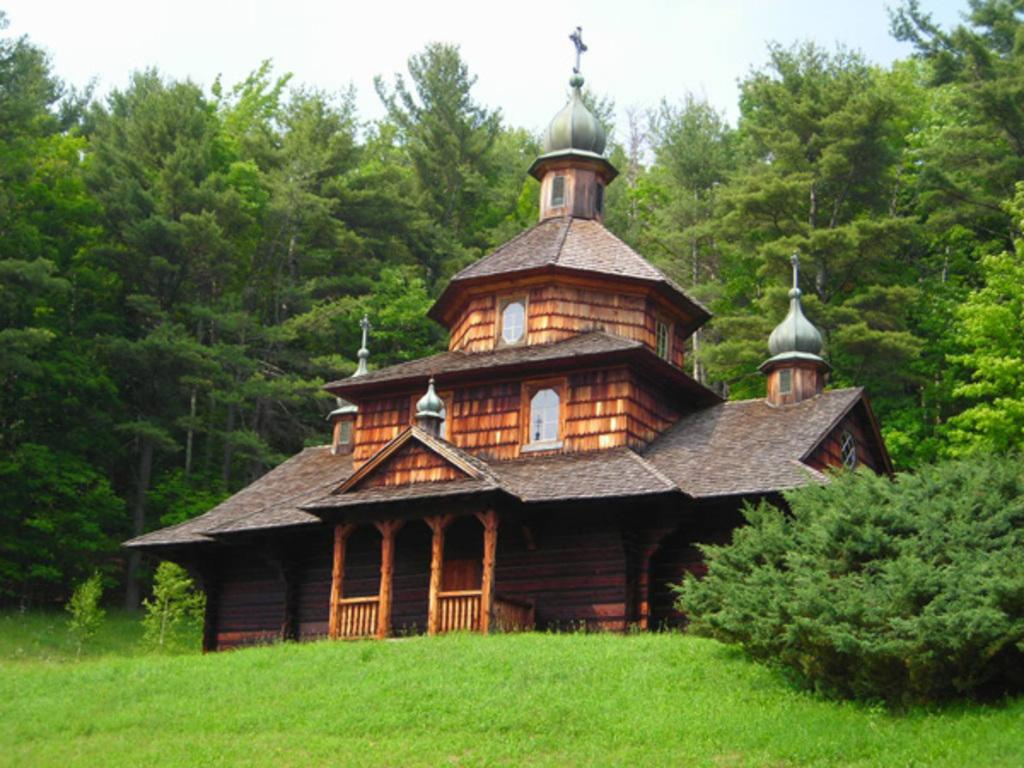What type of structure is visible in the image? There is a house in the image. What can be seen behind the house? There are trees behind the house. What type of vegetation is in front of the house? There is grass in front of the house. What is the value of the thrill experienced by the low-flying birds in the image? There are no birds present in the image, so it is not possible to determine the value of any thrill experienced by them. 